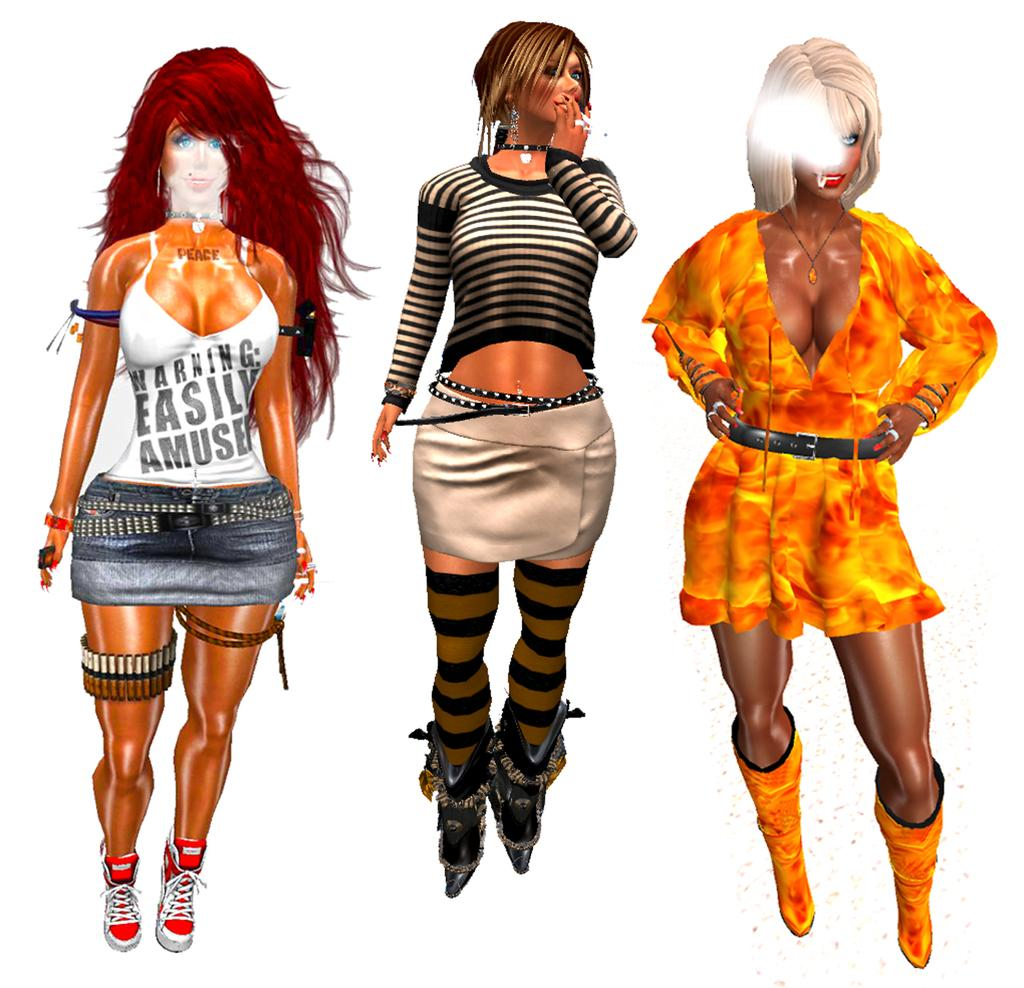Provide a one-sentence caption for the provided image. Three computer animations of women are lined up, with the first one wearing a shirt that says Warning - Easily Amused. 